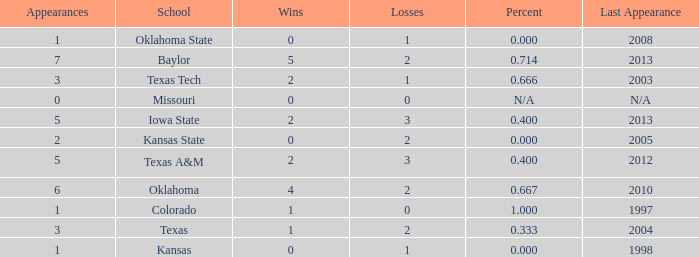How many schools had the win loss ratio of 0.667?  1.0. 